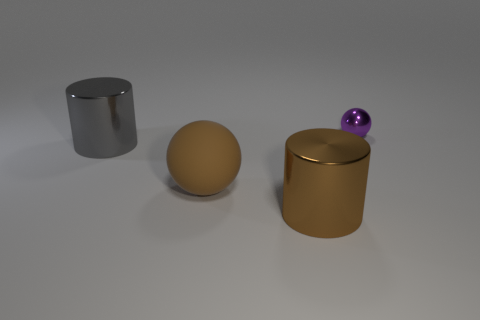Add 4 tiny purple spheres. How many objects exist? 8 Add 3 small metallic things. How many small metallic things are left? 4 Add 3 shiny spheres. How many shiny spheres exist? 4 Subtract 0 red blocks. How many objects are left? 4 Subtract all large yellow metal cylinders. Subtract all purple spheres. How many objects are left? 3 